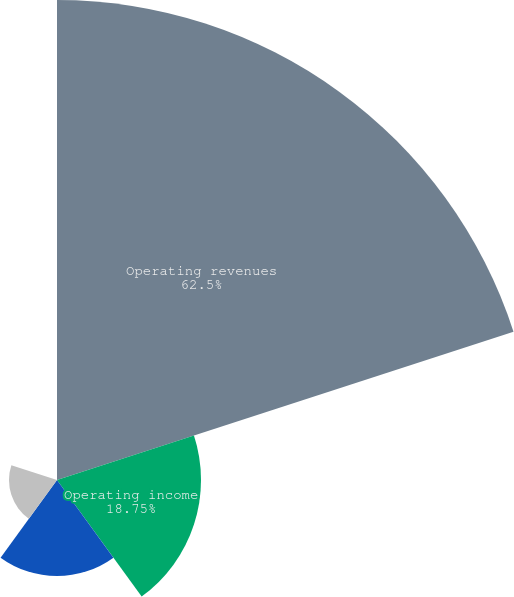Convert chart to OTSL. <chart><loc_0><loc_0><loc_500><loc_500><pie_chart><fcel>Operating revenues<fcel>Operating income<fcel>Net earnings<fcel>Basic earnings per share<fcel>Diluted earnings per share<nl><fcel>62.5%<fcel>18.75%<fcel>12.5%<fcel>6.25%<fcel>0.0%<nl></chart> 